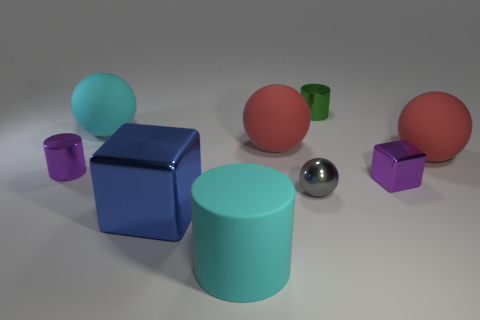What is the size of the cyan matte thing in front of the gray metal thing?
Ensure brevity in your answer.  Large. What is the shape of the blue object that is the same material as the tiny block?
Your answer should be compact. Cube. Do the small gray object and the large blue cube on the left side of the small metal ball have the same material?
Provide a succinct answer. Yes. There is a matte thing left of the big blue cube; does it have the same shape as the small gray thing?
Make the answer very short. Yes. What is the material of the large cyan object that is the same shape as the green thing?
Provide a short and direct response. Rubber. There is a big metal object; is its shape the same as the purple object right of the big block?
Your answer should be compact. Yes. There is a cylinder that is both behind the purple block and right of the cyan ball; what color is it?
Make the answer very short. Green. Is there a big shiny block?
Your response must be concise. Yes. Are there an equal number of cyan rubber things that are in front of the purple block and blue blocks?
Keep it short and to the point. Yes. How many other things are there of the same shape as the large blue shiny object?
Give a very brief answer. 1. 